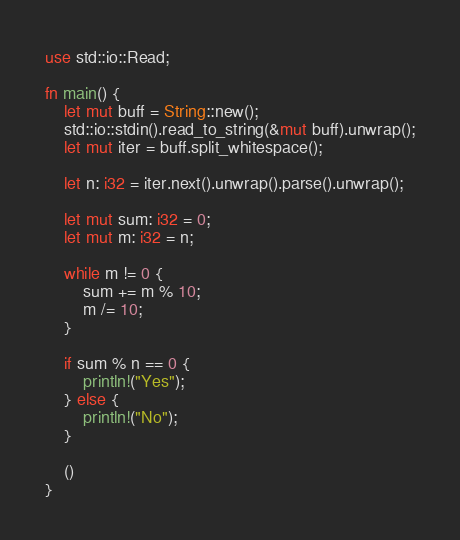<code> <loc_0><loc_0><loc_500><loc_500><_Rust_>use std::io::Read;

fn main() {
    let mut buff = String::new();
    std::io::stdin().read_to_string(&mut buff).unwrap();
    let mut iter = buff.split_whitespace();

    let n: i32 = iter.next().unwrap().parse().unwrap();

    let mut sum: i32 = 0;
    let mut m: i32 = n;

    while m != 0 {
        sum += m % 10;
        m /= 10;
    }

    if sum % n == 0 {
        println!("Yes");
    } else {
        println!("No");
    }

    ()
}
</code> 